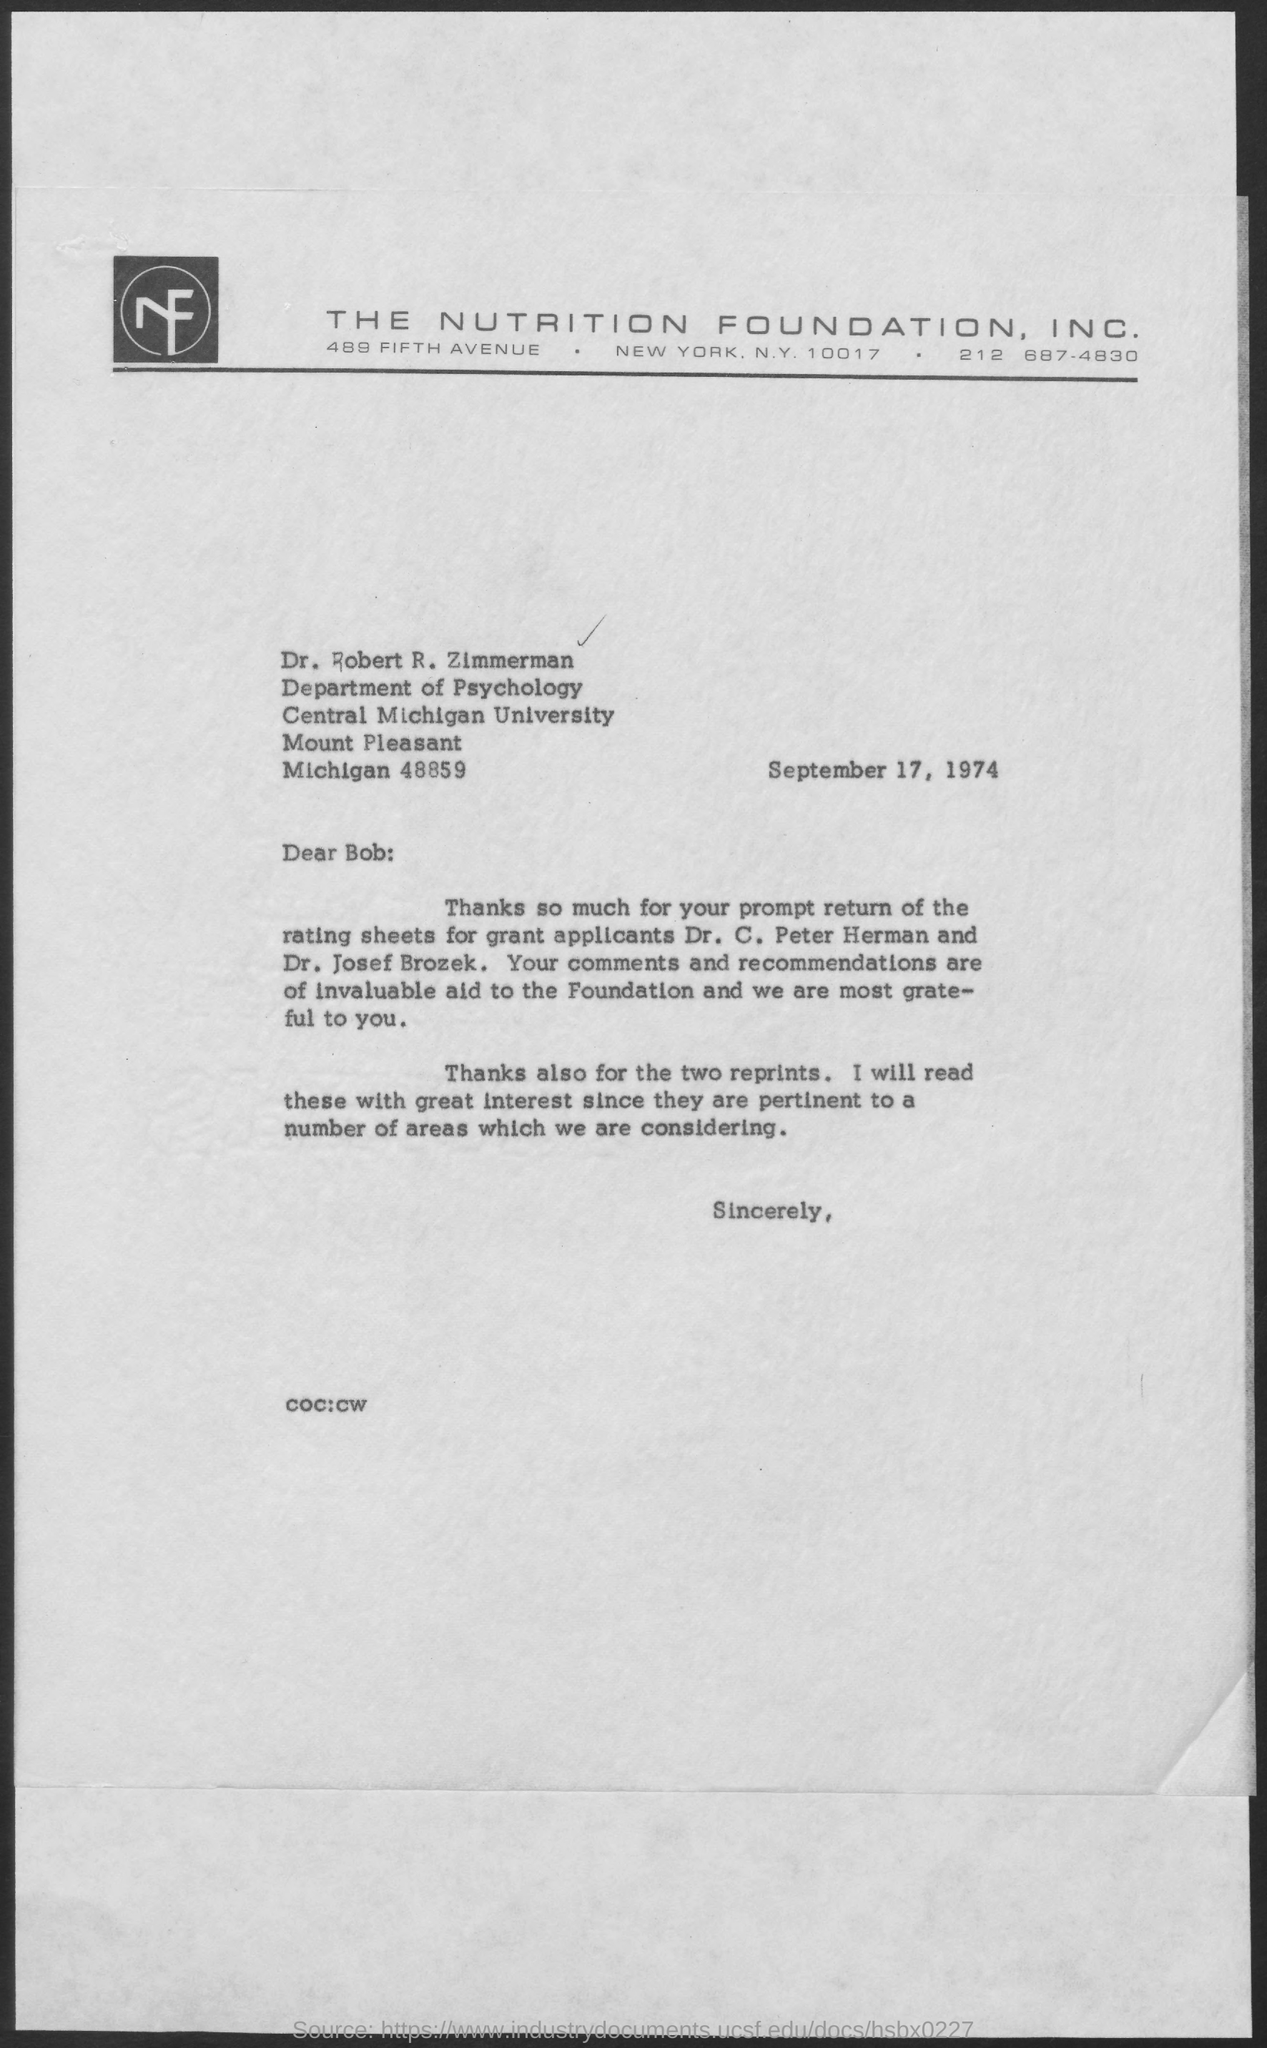To whom this letter is written to?
Your answer should be compact. Dr. Robert R. Zimmerman. 